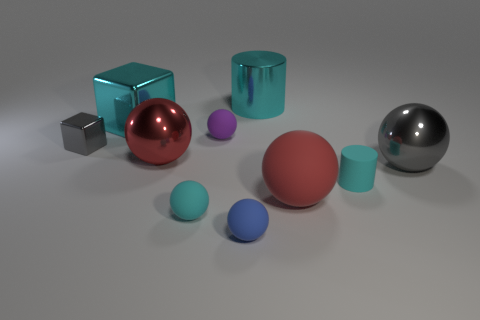What is the material of the small cylinder that is the same color as the big cylinder?
Offer a very short reply. Rubber. There is a small purple thing that is the same shape as the large red metallic object; what material is it?
Offer a very short reply. Rubber. There is a cyan metal object on the right side of the blue ball; is it the same size as the large cube?
Your response must be concise. Yes. What number of rubber things are blue objects or small purple balls?
Keep it short and to the point. 2. There is a small object that is on the left side of the small purple thing and in front of the large red rubber thing; what material is it?
Your answer should be compact. Rubber. Is the tiny blue ball made of the same material as the small cube?
Offer a very short reply. No. There is a thing that is both behind the small purple matte thing and to the left of the small cyan matte ball; how big is it?
Ensure brevity in your answer.  Large. The tiny metal thing has what shape?
Offer a terse response. Cube. How many objects are red objects or gray metallic objects left of the tiny cyan rubber cylinder?
Your response must be concise. 3. There is a big cylinder right of the red metallic sphere; is its color the same as the big metallic block?
Make the answer very short. Yes. 